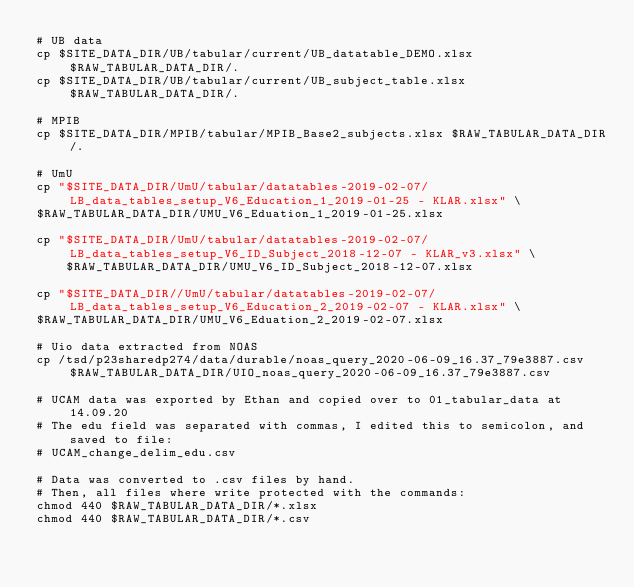Convert code to text. <code><loc_0><loc_0><loc_500><loc_500><_Bash_># UB data
cp $SITE_DATA_DIR/UB/tabular/current/UB_datatable_DEMO.xlsx $RAW_TABULAR_DATA_DIR/.
cp $SITE_DATA_DIR/UB/tabular/current/UB_subject_table.xlsx $RAW_TABULAR_DATA_DIR/.

# MPIB
cp $SITE_DATA_DIR/MPIB/tabular/MPIB_Base2_subjects.xlsx $RAW_TABULAR_DATA_DIR/.

# UmU
cp "$SITE_DATA_DIR/UmU/tabular/datatables-2019-02-07/LB_data_tables_setup_V6_Education_1_2019-01-25 - KLAR.xlsx" \
$RAW_TABULAR_DATA_DIR/UMU_V6_Eduation_1_2019-01-25.xlsx

cp "$SITE_DATA_DIR/UmU/tabular/datatables-2019-02-07/LB_data_tables_setup_V6_ID_Subject_2018-12-07 - KLAR_v3.xlsx" \
    $RAW_TABULAR_DATA_DIR/UMU_V6_ID_Subject_2018-12-07.xlsx

cp "$SITE_DATA_DIR//UmU/tabular/datatables-2019-02-07/LB_data_tables_setup_V6_Education_2_2019-02-07 - KLAR.xlsx" \
$RAW_TABULAR_DATA_DIR/UMU_V6_Eduation_2_2019-02-07.xlsx

# Uio data extracted from NOAS
cp /tsd/p23sharedp274/data/durable/noas_query_2020-06-09_16.37_79e3887.csv $RAW_TABULAR_DATA_DIR/UIO_noas_query_2020-06-09_16.37_79e3887.csv

# UCAM data was exported by Ethan and copied over to 01_tabular_data at 14.09.20
# The edu field was separated with commas, I edited this to semicolon, and saved to file:
# UCAM_change_delim_edu.csv

# Data was converted to .csv files by hand. 
# Then, all files where write protected with the commands:
chmod 440 $RAW_TABULAR_DATA_DIR/*.xlsx
chmod 440 $RAW_TABULAR_DATA_DIR/*.csv</code> 